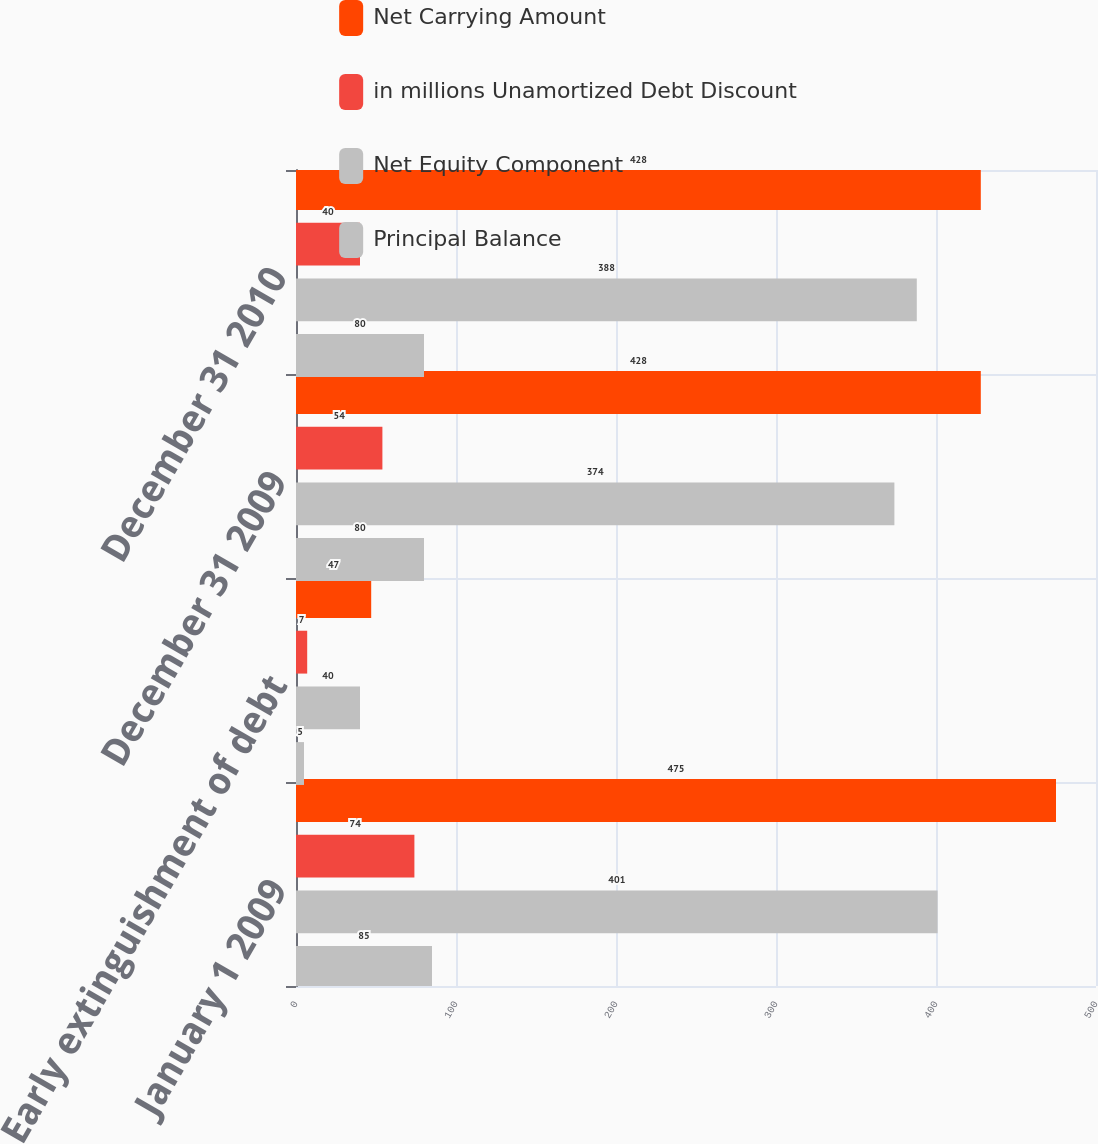Convert chart. <chart><loc_0><loc_0><loc_500><loc_500><stacked_bar_chart><ecel><fcel>January 1 2009<fcel>Early extinguishment of debt<fcel>December 31 2009<fcel>December 31 2010<nl><fcel>Net Carrying Amount<fcel>475<fcel>47<fcel>428<fcel>428<nl><fcel>in millions Unamortized Debt Discount<fcel>74<fcel>7<fcel>54<fcel>40<nl><fcel>Net Equity Component<fcel>401<fcel>40<fcel>374<fcel>388<nl><fcel>Principal Balance<fcel>85<fcel>5<fcel>80<fcel>80<nl></chart> 